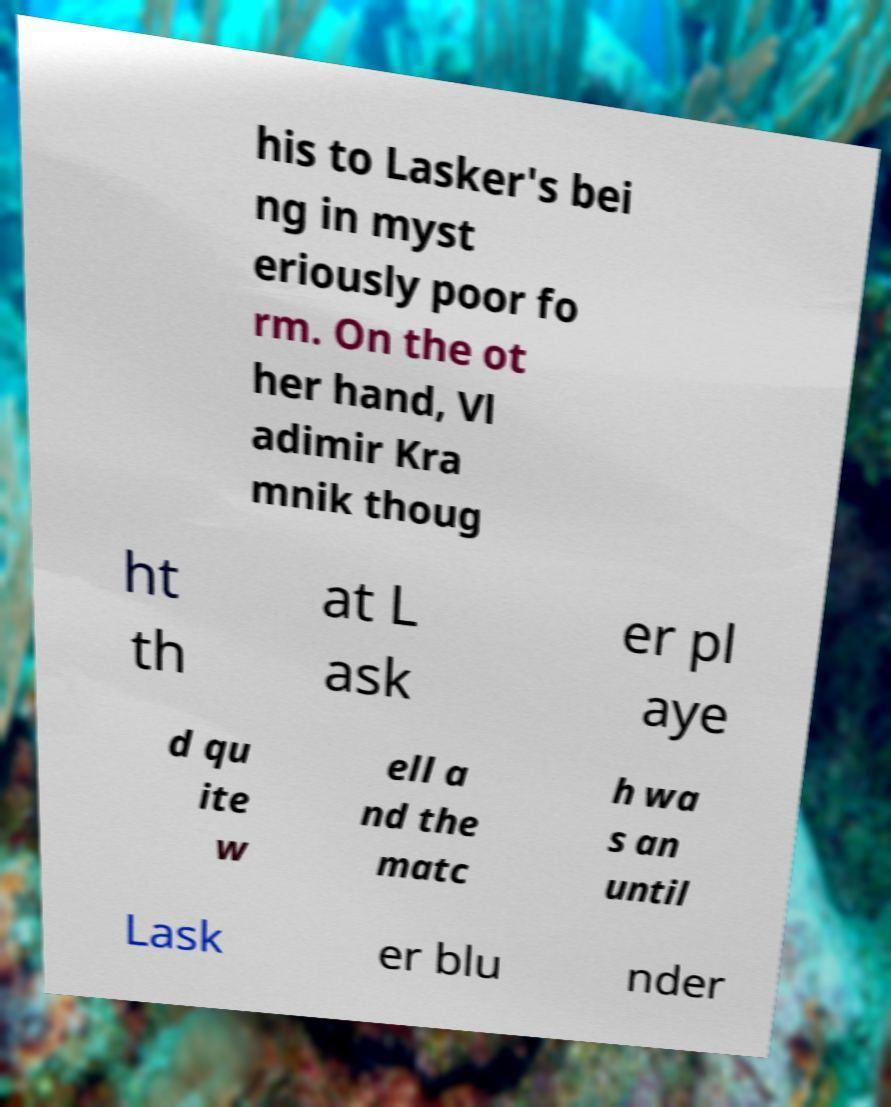Can you accurately transcribe the text from the provided image for me? his to Lasker's bei ng in myst eriously poor fo rm. On the ot her hand, Vl adimir Kra mnik thoug ht th at L ask er pl aye d qu ite w ell a nd the matc h wa s an until Lask er blu nder 